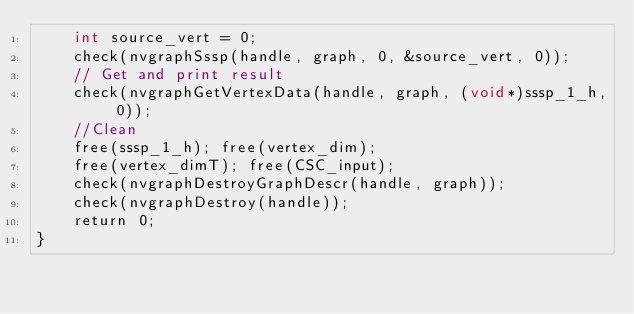<code> <loc_0><loc_0><loc_500><loc_500><_Cuda_>	int source_vert = 0;
	check(nvgraphSssp(handle, graph, 0, &source_vert, 0));
	// Get and print result
	check(nvgraphGetVertexData(handle, graph, (void*)sssp_1_h, 0));
	//Clean
	free(sssp_1_h); free(vertex_dim);
	free(vertex_dimT); free(CSC_input);
	check(nvgraphDestroyGraphDescr(handle, graph));
	check(nvgraphDestroy(handle));
	return 0;
}
</code> 